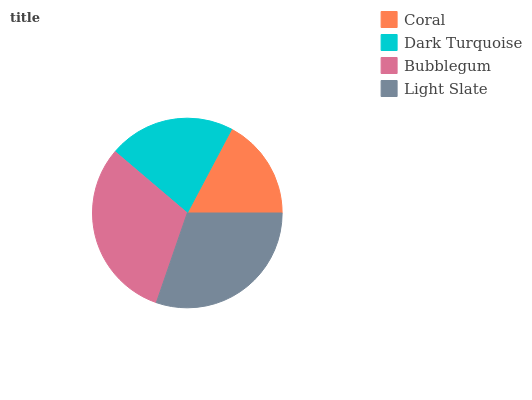Is Coral the minimum?
Answer yes or no. Yes. Is Bubblegum the maximum?
Answer yes or no. Yes. Is Dark Turquoise the minimum?
Answer yes or no. No. Is Dark Turquoise the maximum?
Answer yes or no. No. Is Dark Turquoise greater than Coral?
Answer yes or no. Yes. Is Coral less than Dark Turquoise?
Answer yes or no. Yes. Is Coral greater than Dark Turquoise?
Answer yes or no. No. Is Dark Turquoise less than Coral?
Answer yes or no. No. Is Light Slate the high median?
Answer yes or no. Yes. Is Dark Turquoise the low median?
Answer yes or no. Yes. Is Dark Turquoise the high median?
Answer yes or no. No. Is Light Slate the low median?
Answer yes or no. No. 